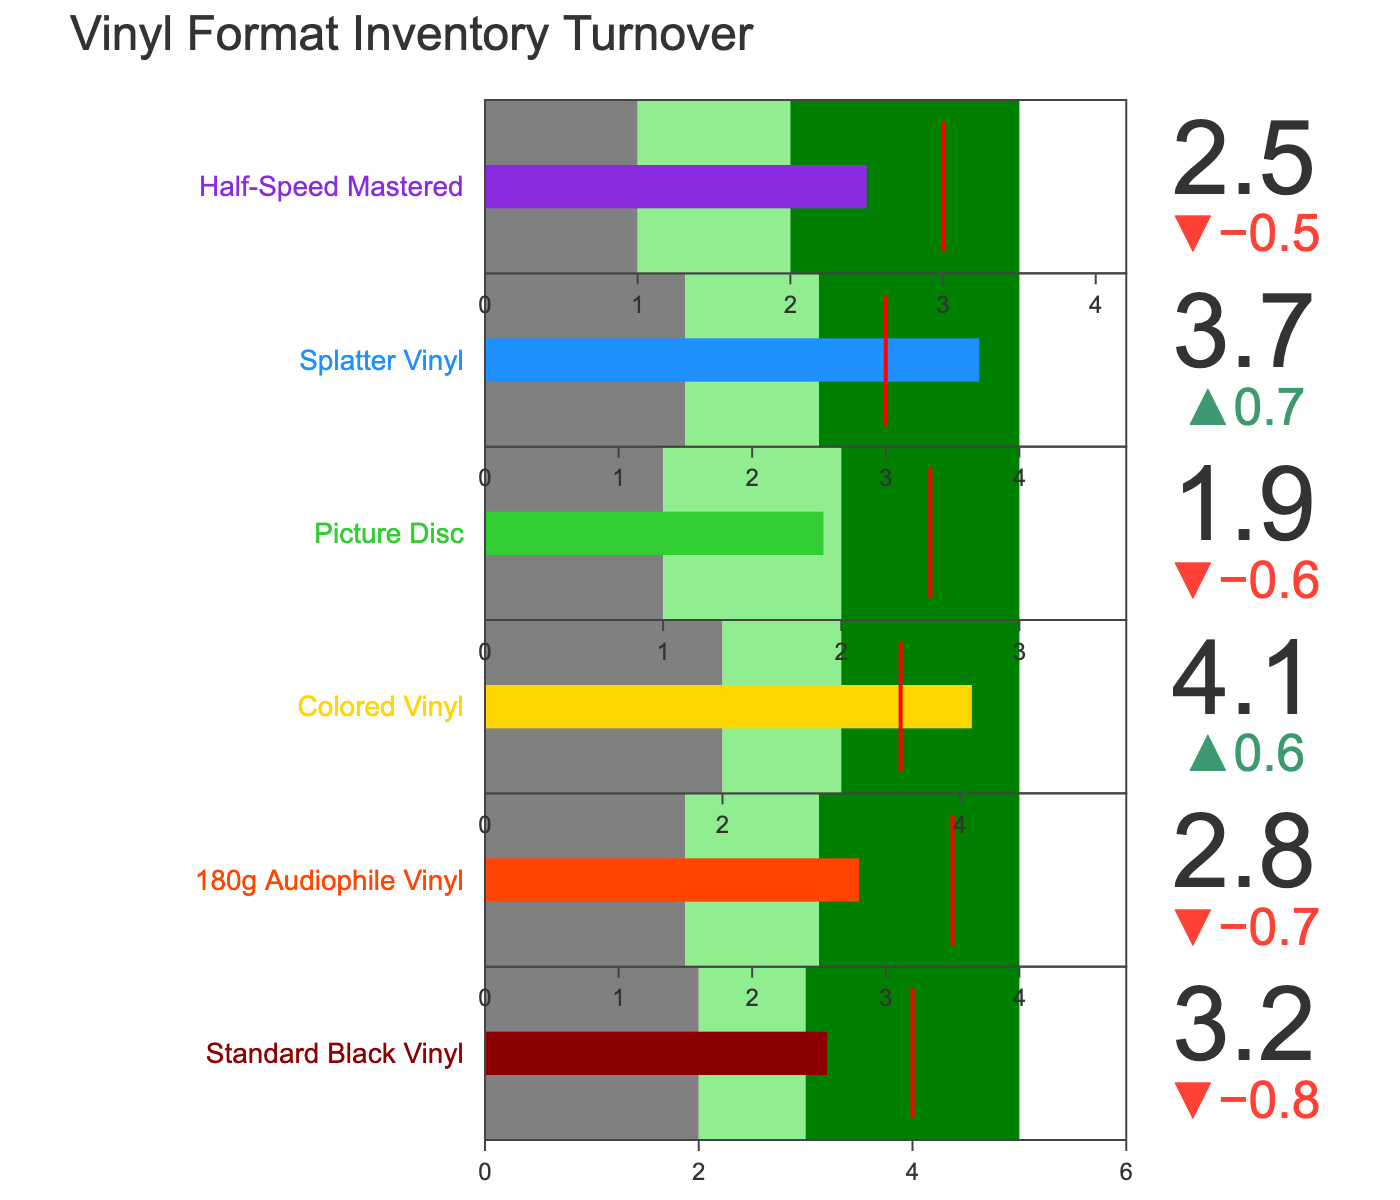What's the highest inventory turnover rate among the vinyl formats? Scan all the actual turnover rates for each format in the figure: Standard Black Vinyl (3.2), 180g Audiophile Vinyl (2.8), Colored Vinyl (4.1), Picture Disc (1.9), Splatter Vinyl (3.7), Half-Speed Mastered (2.5). The highest value is 4.1 for Colored Vinyl.
Answer: 4.1 Which format has an inventory turnover rate closest to its target? Compare the actual turnovers and target turnovers for each format: Standard Black Vinyl (3.2 vs 4), 180g Audiophile Vinyl (2.8 vs 3.5), Colored Vinyl (4.1 vs 3.5), Picture Disc (1.9 vs 2.5), Splatter Vinyl (3.7 vs 3), Half-Speed Mastered (2.5 vs 3). The smallest difference is for Splatter Vinyl (3.7 vs 3).
Answer: Splatter Vinyl How does the actual inventory turnover rate for Half-Speed Mastered Vinyl compare to its satisfactory range? The satisfactory range for Half-Speed Mastered Vinyl is from 1 to 2. The actual turnover rate is 2.5. Since 2.5 is higher than the satisfactory range, it exceeds this range.
Answer: Exceeds Which vinyl format has the target turnover rate of 3.5? Look at the target turnover rates in the figure. 180g Audiophile Vinyl and Colored Vinyl both have a target turnover rate of 3.5.
Answer: 180g Audiophile Vinyl, Colored Vinyl What is the optimal stock level for Colored Vinyl according to the excellent range? The excellent range for Colored Vinyl is from 4 to 4.5. Thus, the optimal stock level would be within this range.
Answer: 4 to 4.5 Between Splatter Vinyl and Picture Disc, which one has a higher actual turnover rate and by how much? Compare the actual turnover rates: Splatter Vinyl (3.7) and Picture Disc (1.9). The difference is 3.7 - 1.9 = 1.8.
Answer: Splatter Vinyl, 1.8 Identify the format with the lowest actual inventory turnover rate and state if it meets the poor range threshold. The lowest actual turnover rate is for Picture Disc (1.9). The poor range threshold is from 0 to 1. Since 1.9 is greater than 1, it exceeds the poor range.
Answer: Picture Disc, Exceeds For which vinyl format is the actual turnover rate greater than the excellent range? Compare actual turnover rates with excellent ranges: Standard Black Vinyl (3.2 vs 5), 180g Audiophile Vinyl (2.8 vs 4), Colored Vinyl (4.1 vs 4.5), Picture Disc (1.9 vs 3), Splatter Vinyl (3.7 vs 4), Half-Speed Mastered (2.5 vs 3.5). None of the actual turnover rates exceed their excellent ranges.
Answer: None What's the difference between the actual turnover rate and the target turnover rate for the Standard Black Vinyl? The actual turnover rate and target turnover rate for Standard Black Vinyl are 3.2 and 4 respectively. The difference is 4 - 3.2 = 0.8.
Answer: 0.8 